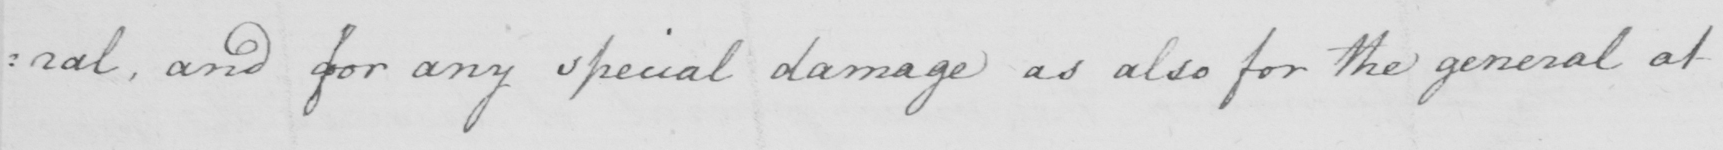Can you tell me what this handwritten text says? : ral , and for any special damage as also for the general at 